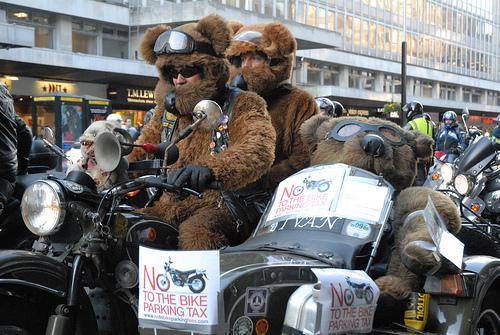How many bears are in the picture?
Quick response, please. 3. What are they on?
Answer briefly. Motorcycle. What animal is on the motorcycles?
Concise answer only. Bear. 